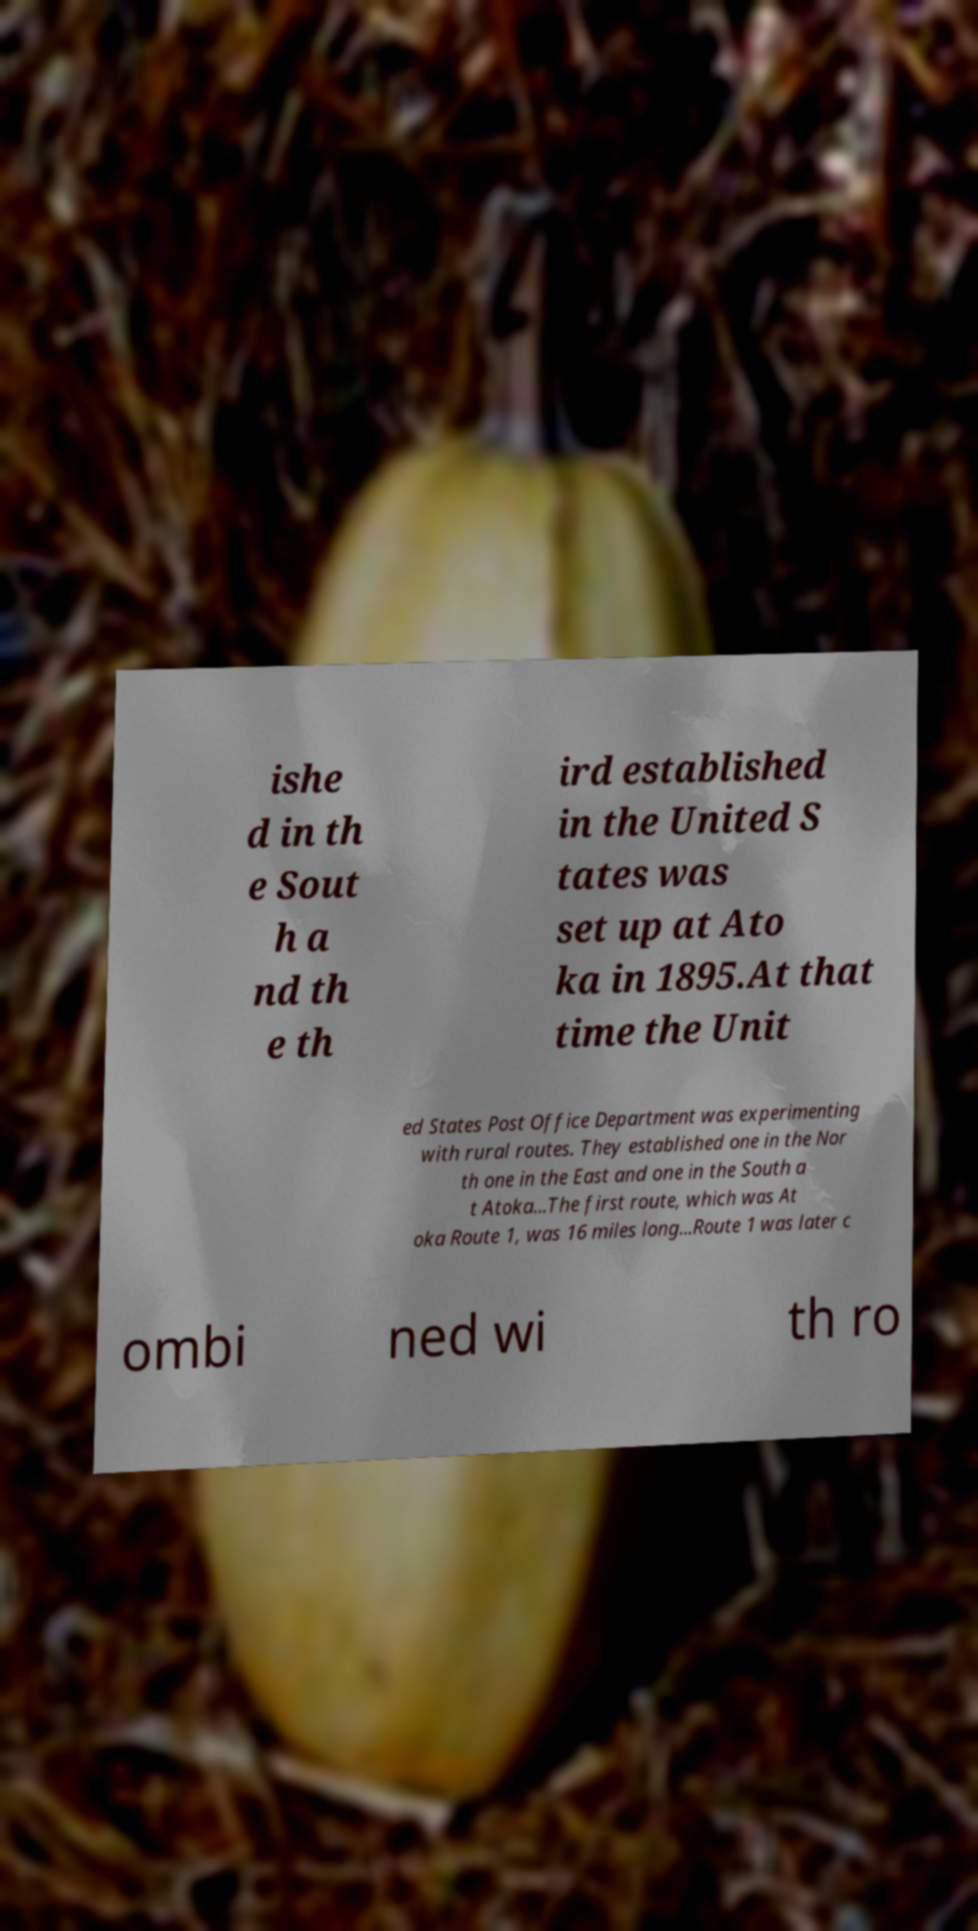Please identify and transcribe the text found in this image. ishe d in th e Sout h a nd th e th ird established in the United S tates was set up at Ato ka in 1895.At that time the Unit ed States Post Office Department was experimenting with rural routes. They established one in the Nor th one in the East and one in the South a t Atoka...The first route, which was At oka Route 1, was 16 miles long...Route 1 was later c ombi ned wi th ro 